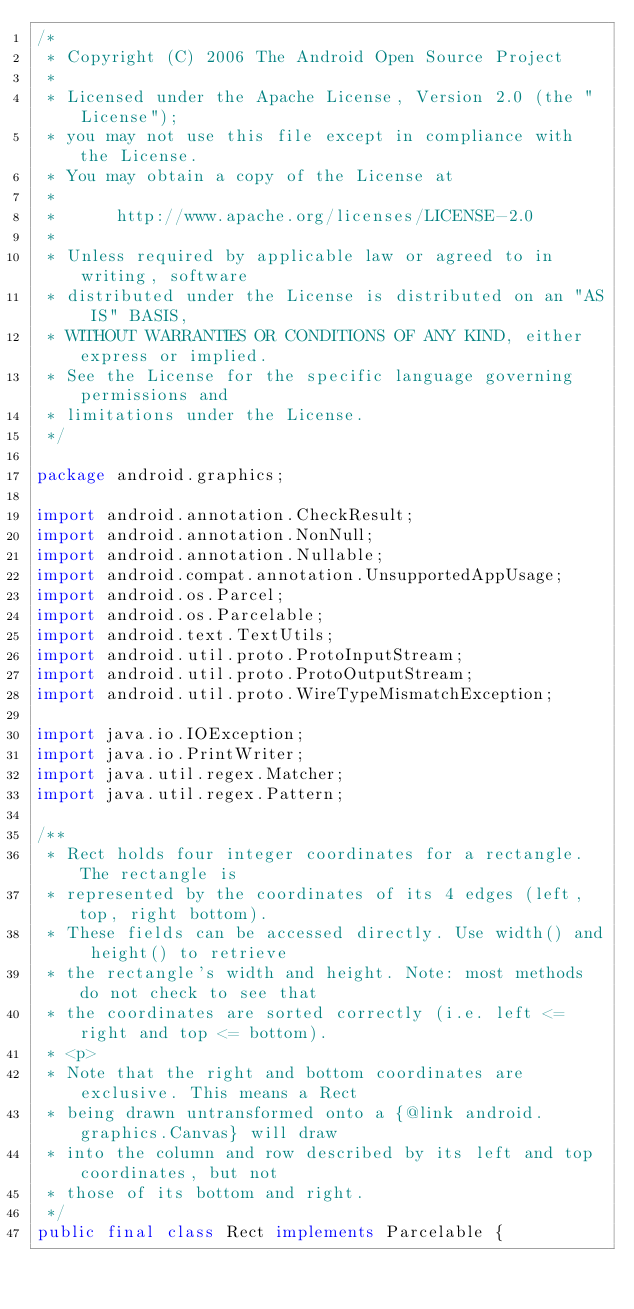Convert code to text. <code><loc_0><loc_0><loc_500><loc_500><_Java_>/*
 * Copyright (C) 2006 The Android Open Source Project
 *
 * Licensed under the Apache License, Version 2.0 (the "License");
 * you may not use this file except in compliance with the License.
 * You may obtain a copy of the License at
 *
 *      http://www.apache.org/licenses/LICENSE-2.0
 *
 * Unless required by applicable law or agreed to in writing, software
 * distributed under the License is distributed on an "AS IS" BASIS,
 * WITHOUT WARRANTIES OR CONDITIONS OF ANY KIND, either express or implied.
 * See the License for the specific language governing permissions and
 * limitations under the License.
 */

package android.graphics;

import android.annotation.CheckResult;
import android.annotation.NonNull;
import android.annotation.Nullable;
import android.compat.annotation.UnsupportedAppUsage;
import android.os.Parcel;
import android.os.Parcelable;
import android.text.TextUtils;
import android.util.proto.ProtoInputStream;
import android.util.proto.ProtoOutputStream;
import android.util.proto.WireTypeMismatchException;

import java.io.IOException;
import java.io.PrintWriter;
import java.util.regex.Matcher;
import java.util.regex.Pattern;

/**
 * Rect holds four integer coordinates for a rectangle. The rectangle is
 * represented by the coordinates of its 4 edges (left, top, right bottom).
 * These fields can be accessed directly. Use width() and height() to retrieve
 * the rectangle's width and height. Note: most methods do not check to see that
 * the coordinates are sorted correctly (i.e. left <= right and top <= bottom).
 * <p>
 * Note that the right and bottom coordinates are exclusive. This means a Rect
 * being drawn untransformed onto a {@link android.graphics.Canvas} will draw
 * into the column and row described by its left and top coordinates, but not
 * those of its bottom and right.
 */
public final class Rect implements Parcelable {</code> 